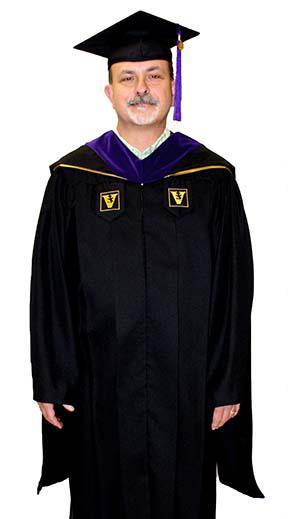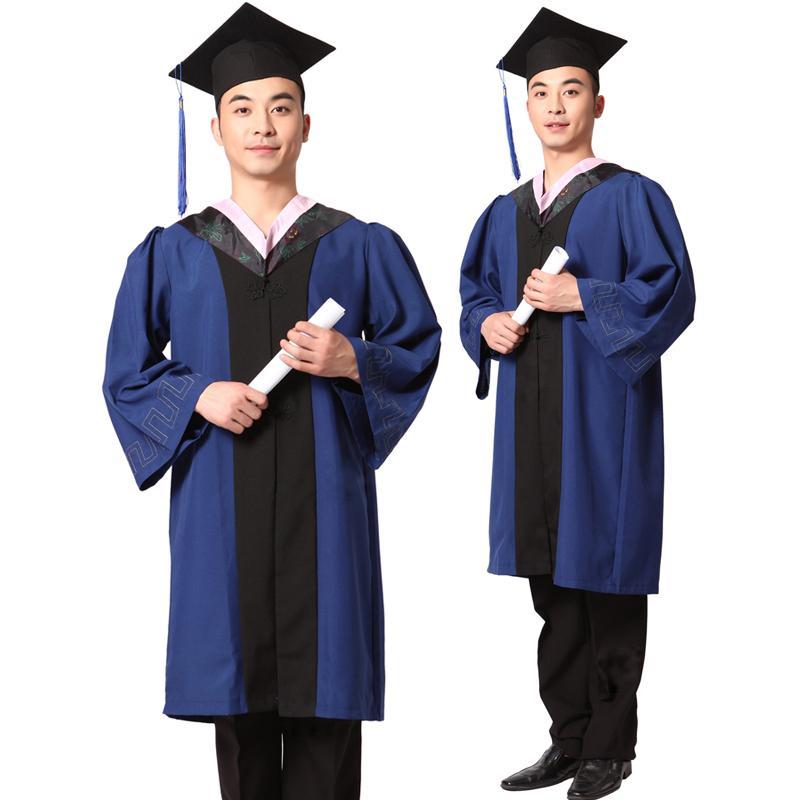The first image is the image on the left, the second image is the image on the right. For the images shown, is this caption "An image shows a mannequin wearing a graduation robe with black stripes on its sleeves." true? Answer yes or no. No. The first image is the image on the left, the second image is the image on the right. For the images displayed, is the sentence "All graduation gowns and caps with tassles are modeled by real people, but only person is shown full length from head to foot." factually correct? Answer yes or no. Yes. 